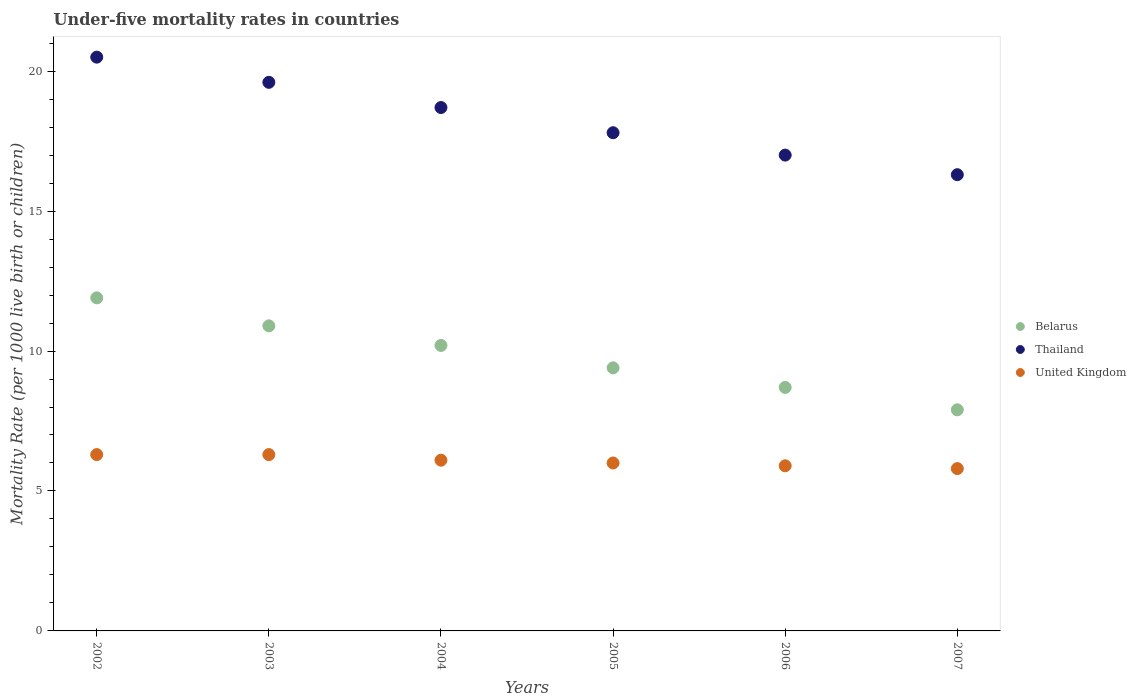How many different coloured dotlines are there?
Your answer should be compact. 3. Is the number of dotlines equal to the number of legend labels?
Provide a succinct answer. Yes. Across all years, what is the minimum under-five mortality rate in United Kingdom?
Your response must be concise. 5.8. In which year was the under-five mortality rate in Thailand maximum?
Your answer should be very brief. 2002. In which year was the under-five mortality rate in Belarus minimum?
Offer a very short reply. 2007. What is the total under-five mortality rate in Thailand in the graph?
Provide a short and direct response. 109.9. What is the difference between the under-five mortality rate in Thailand in 2002 and that in 2005?
Your answer should be compact. 2.7. What is the difference between the under-five mortality rate in United Kingdom in 2002 and the under-five mortality rate in Thailand in 2007?
Your answer should be very brief. -10. What is the average under-five mortality rate in Belarus per year?
Make the answer very short. 9.83. In the year 2007, what is the difference between the under-five mortality rate in Belarus and under-five mortality rate in United Kingdom?
Give a very brief answer. 2.1. What is the ratio of the under-five mortality rate in United Kingdom in 2004 to that in 2006?
Provide a short and direct response. 1.03. Is the under-five mortality rate in Thailand in 2002 less than that in 2007?
Your answer should be compact. No. Is the difference between the under-five mortality rate in Belarus in 2005 and 2006 greater than the difference between the under-five mortality rate in United Kingdom in 2005 and 2006?
Your answer should be very brief. Yes. What is the difference between the highest and the second highest under-five mortality rate in Thailand?
Offer a very short reply. 0.9. Is it the case that in every year, the sum of the under-five mortality rate in United Kingdom and under-five mortality rate in Belarus  is greater than the under-five mortality rate in Thailand?
Your response must be concise. No. Is the under-five mortality rate in Belarus strictly less than the under-five mortality rate in Thailand over the years?
Give a very brief answer. Yes. Are the values on the major ticks of Y-axis written in scientific E-notation?
Give a very brief answer. No. Where does the legend appear in the graph?
Ensure brevity in your answer.  Center right. What is the title of the graph?
Keep it short and to the point. Under-five mortality rates in countries. Does "Ghana" appear as one of the legend labels in the graph?
Provide a succinct answer. No. What is the label or title of the Y-axis?
Offer a very short reply. Mortality Rate (per 1000 live birth or children). What is the Mortality Rate (per 1000 live birth or children) of Belarus in 2002?
Your answer should be compact. 11.9. What is the Mortality Rate (per 1000 live birth or children) of Thailand in 2002?
Provide a short and direct response. 20.5. What is the Mortality Rate (per 1000 live birth or children) in Thailand in 2003?
Keep it short and to the point. 19.6. What is the Mortality Rate (per 1000 live birth or children) of United Kingdom in 2003?
Make the answer very short. 6.3. What is the Mortality Rate (per 1000 live birth or children) of Belarus in 2004?
Your response must be concise. 10.2. What is the Mortality Rate (per 1000 live birth or children) in Belarus in 2006?
Ensure brevity in your answer.  8.7. What is the Mortality Rate (per 1000 live birth or children) of United Kingdom in 2006?
Your response must be concise. 5.9. What is the Mortality Rate (per 1000 live birth or children) of United Kingdom in 2007?
Offer a terse response. 5.8. Across all years, what is the minimum Mortality Rate (per 1000 live birth or children) of Belarus?
Your answer should be very brief. 7.9. Across all years, what is the minimum Mortality Rate (per 1000 live birth or children) in Thailand?
Your response must be concise. 16.3. What is the total Mortality Rate (per 1000 live birth or children) of Belarus in the graph?
Your response must be concise. 59. What is the total Mortality Rate (per 1000 live birth or children) of Thailand in the graph?
Make the answer very short. 109.9. What is the total Mortality Rate (per 1000 live birth or children) of United Kingdom in the graph?
Provide a short and direct response. 36.4. What is the difference between the Mortality Rate (per 1000 live birth or children) of Belarus in 2002 and that in 2003?
Provide a short and direct response. 1. What is the difference between the Mortality Rate (per 1000 live birth or children) of Thailand in 2002 and that in 2003?
Your answer should be very brief. 0.9. What is the difference between the Mortality Rate (per 1000 live birth or children) in Thailand in 2002 and that in 2005?
Ensure brevity in your answer.  2.7. What is the difference between the Mortality Rate (per 1000 live birth or children) of United Kingdom in 2002 and that in 2005?
Provide a short and direct response. 0.3. What is the difference between the Mortality Rate (per 1000 live birth or children) in Belarus in 2002 and that in 2006?
Make the answer very short. 3.2. What is the difference between the Mortality Rate (per 1000 live birth or children) of Thailand in 2002 and that in 2006?
Make the answer very short. 3.5. What is the difference between the Mortality Rate (per 1000 live birth or children) in United Kingdom in 2002 and that in 2006?
Make the answer very short. 0.4. What is the difference between the Mortality Rate (per 1000 live birth or children) of Thailand in 2002 and that in 2007?
Offer a very short reply. 4.2. What is the difference between the Mortality Rate (per 1000 live birth or children) of Belarus in 2003 and that in 2004?
Your response must be concise. 0.7. What is the difference between the Mortality Rate (per 1000 live birth or children) in Belarus in 2003 and that in 2005?
Make the answer very short. 1.5. What is the difference between the Mortality Rate (per 1000 live birth or children) of United Kingdom in 2003 and that in 2005?
Your answer should be very brief. 0.3. What is the difference between the Mortality Rate (per 1000 live birth or children) in Belarus in 2003 and that in 2006?
Keep it short and to the point. 2.2. What is the difference between the Mortality Rate (per 1000 live birth or children) in Thailand in 2003 and that in 2006?
Your response must be concise. 2.6. What is the difference between the Mortality Rate (per 1000 live birth or children) in Belarus in 2003 and that in 2007?
Your answer should be compact. 3. What is the difference between the Mortality Rate (per 1000 live birth or children) of Thailand in 2003 and that in 2007?
Your answer should be compact. 3.3. What is the difference between the Mortality Rate (per 1000 live birth or children) of United Kingdom in 2003 and that in 2007?
Your response must be concise. 0.5. What is the difference between the Mortality Rate (per 1000 live birth or children) of Belarus in 2004 and that in 2005?
Give a very brief answer. 0.8. What is the difference between the Mortality Rate (per 1000 live birth or children) in Thailand in 2004 and that in 2005?
Ensure brevity in your answer.  0.9. What is the difference between the Mortality Rate (per 1000 live birth or children) in Thailand in 2004 and that in 2006?
Give a very brief answer. 1.7. What is the difference between the Mortality Rate (per 1000 live birth or children) in Thailand in 2004 and that in 2007?
Your response must be concise. 2.4. What is the difference between the Mortality Rate (per 1000 live birth or children) of Belarus in 2005 and that in 2006?
Ensure brevity in your answer.  0.7. What is the difference between the Mortality Rate (per 1000 live birth or children) in United Kingdom in 2005 and that in 2006?
Offer a terse response. 0.1. What is the difference between the Mortality Rate (per 1000 live birth or children) in Belarus in 2005 and that in 2007?
Your answer should be compact. 1.5. What is the difference between the Mortality Rate (per 1000 live birth or children) in United Kingdom in 2005 and that in 2007?
Ensure brevity in your answer.  0.2. What is the difference between the Mortality Rate (per 1000 live birth or children) in Thailand in 2006 and that in 2007?
Keep it short and to the point. 0.7. What is the difference between the Mortality Rate (per 1000 live birth or children) in United Kingdom in 2006 and that in 2007?
Your response must be concise. 0.1. What is the difference between the Mortality Rate (per 1000 live birth or children) in Belarus in 2002 and the Mortality Rate (per 1000 live birth or children) in Thailand in 2003?
Your response must be concise. -7.7. What is the difference between the Mortality Rate (per 1000 live birth or children) of Belarus in 2002 and the Mortality Rate (per 1000 live birth or children) of Thailand in 2004?
Keep it short and to the point. -6.8. What is the difference between the Mortality Rate (per 1000 live birth or children) of Belarus in 2002 and the Mortality Rate (per 1000 live birth or children) of United Kingdom in 2004?
Make the answer very short. 5.8. What is the difference between the Mortality Rate (per 1000 live birth or children) of Belarus in 2002 and the Mortality Rate (per 1000 live birth or children) of Thailand in 2006?
Give a very brief answer. -5.1. What is the difference between the Mortality Rate (per 1000 live birth or children) of Thailand in 2002 and the Mortality Rate (per 1000 live birth or children) of United Kingdom in 2006?
Make the answer very short. 14.6. What is the difference between the Mortality Rate (per 1000 live birth or children) in Belarus in 2002 and the Mortality Rate (per 1000 live birth or children) in Thailand in 2007?
Your answer should be very brief. -4.4. What is the difference between the Mortality Rate (per 1000 live birth or children) in Belarus in 2003 and the Mortality Rate (per 1000 live birth or children) in Thailand in 2004?
Make the answer very short. -7.8. What is the difference between the Mortality Rate (per 1000 live birth or children) in Belarus in 2003 and the Mortality Rate (per 1000 live birth or children) in United Kingdom in 2004?
Make the answer very short. 4.8. What is the difference between the Mortality Rate (per 1000 live birth or children) of Thailand in 2003 and the Mortality Rate (per 1000 live birth or children) of United Kingdom in 2004?
Give a very brief answer. 13.5. What is the difference between the Mortality Rate (per 1000 live birth or children) of Belarus in 2003 and the Mortality Rate (per 1000 live birth or children) of Thailand in 2005?
Offer a terse response. -6.9. What is the difference between the Mortality Rate (per 1000 live birth or children) of Belarus in 2003 and the Mortality Rate (per 1000 live birth or children) of United Kingdom in 2005?
Offer a very short reply. 4.9. What is the difference between the Mortality Rate (per 1000 live birth or children) in Thailand in 2003 and the Mortality Rate (per 1000 live birth or children) in United Kingdom in 2005?
Make the answer very short. 13.6. What is the difference between the Mortality Rate (per 1000 live birth or children) of Belarus in 2003 and the Mortality Rate (per 1000 live birth or children) of Thailand in 2006?
Ensure brevity in your answer.  -6.1. What is the difference between the Mortality Rate (per 1000 live birth or children) of Thailand in 2003 and the Mortality Rate (per 1000 live birth or children) of United Kingdom in 2006?
Give a very brief answer. 13.7. What is the difference between the Mortality Rate (per 1000 live birth or children) of Belarus in 2004 and the Mortality Rate (per 1000 live birth or children) of Thailand in 2005?
Ensure brevity in your answer.  -7.6. What is the difference between the Mortality Rate (per 1000 live birth or children) of Belarus in 2004 and the Mortality Rate (per 1000 live birth or children) of United Kingdom in 2005?
Offer a very short reply. 4.2. What is the difference between the Mortality Rate (per 1000 live birth or children) in Thailand in 2004 and the Mortality Rate (per 1000 live birth or children) in United Kingdom in 2005?
Your answer should be very brief. 12.7. What is the difference between the Mortality Rate (per 1000 live birth or children) in Belarus in 2004 and the Mortality Rate (per 1000 live birth or children) in United Kingdom in 2007?
Provide a short and direct response. 4.4. What is the difference between the Mortality Rate (per 1000 live birth or children) in Thailand in 2004 and the Mortality Rate (per 1000 live birth or children) in United Kingdom in 2007?
Offer a terse response. 12.9. What is the difference between the Mortality Rate (per 1000 live birth or children) in Belarus in 2005 and the Mortality Rate (per 1000 live birth or children) in United Kingdom in 2006?
Offer a very short reply. 3.5. What is the difference between the Mortality Rate (per 1000 live birth or children) of Belarus in 2005 and the Mortality Rate (per 1000 live birth or children) of Thailand in 2007?
Keep it short and to the point. -6.9. What is the difference between the Mortality Rate (per 1000 live birth or children) of Belarus in 2005 and the Mortality Rate (per 1000 live birth or children) of United Kingdom in 2007?
Provide a short and direct response. 3.6. What is the difference between the Mortality Rate (per 1000 live birth or children) of Thailand in 2005 and the Mortality Rate (per 1000 live birth or children) of United Kingdom in 2007?
Give a very brief answer. 12. What is the difference between the Mortality Rate (per 1000 live birth or children) of Thailand in 2006 and the Mortality Rate (per 1000 live birth or children) of United Kingdom in 2007?
Offer a very short reply. 11.2. What is the average Mortality Rate (per 1000 live birth or children) of Belarus per year?
Provide a short and direct response. 9.83. What is the average Mortality Rate (per 1000 live birth or children) of Thailand per year?
Offer a very short reply. 18.32. What is the average Mortality Rate (per 1000 live birth or children) in United Kingdom per year?
Make the answer very short. 6.07. In the year 2002, what is the difference between the Mortality Rate (per 1000 live birth or children) of Belarus and Mortality Rate (per 1000 live birth or children) of Thailand?
Make the answer very short. -8.6. In the year 2002, what is the difference between the Mortality Rate (per 1000 live birth or children) in Belarus and Mortality Rate (per 1000 live birth or children) in United Kingdom?
Keep it short and to the point. 5.6. In the year 2002, what is the difference between the Mortality Rate (per 1000 live birth or children) in Thailand and Mortality Rate (per 1000 live birth or children) in United Kingdom?
Offer a terse response. 14.2. In the year 2003, what is the difference between the Mortality Rate (per 1000 live birth or children) of Belarus and Mortality Rate (per 1000 live birth or children) of United Kingdom?
Your answer should be very brief. 4.6. In the year 2004, what is the difference between the Mortality Rate (per 1000 live birth or children) of Belarus and Mortality Rate (per 1000 live birth or children) of Thailand?
Give a very brief answer. -8.5. In the year 2004, what is the difference between the Mortality Rate (per 1000 live birth or children) in Thailand and Mortality Rate (per 1000 live birth or children) in United Kingdom?
Give a very brief answer. 12.6. In the year 2005, what is the difference between the Mortality Rate (per 1000 live birth or children) of Belarus and Mortality Rate (per 1000 live birth or children) of United Kingdom?
Offer a terse response. 3.4. In the year 2005, what is the difference between the Mortality Rate (per 1000 live birth or children) of Thailand and Mortality Rate (per 1000 live birth or children) of United Kingdom?
Provide a short and direct response. 11.8. In the year 2006, what is the difference between the Mortality Rate (per 1000 live birth or children) of Belarus and Mortality Rate (per 1000 live birth or children) of United Kingdom?
Your answer should be very brief. 2.8. In the year 2007, what is the difference between the Mortality Rate (per 1000 live birth or children) in Belarus and Mortality Rate (per 1000 live birth or children) in United Kingdom?
Provide a short and direct response. 2.1. In the year 2007, what is the difference between the Mortality Rate (per 1000 live birth or children) of Thailand and Mortality Rate (per 1000 live birth or children) of United Kingdom?
Ensure brevity in your answer.  10.5. What is the ratio of the Mortality Rate (per 1000 live birth or children) of Belarus in 2002 to that in 2003?
Your answer should be compact. 1.09. What is the ratio of the Mortality Rate (per 1000 live birth or children) of Thailand in 2002 to that in 2003?
Ensure brevity in your answer.  1.05. What is the ratio of the Mortality Rate (per 1000 live birth or children) of United Kingdom in 2002 to that in 2003?
Give a very brief answer. 1. What is the ratio of the Mortality Rate (per 1000 live birth or children) of Belarus in 2002 to that in 2004?
Provide a short and direct response. 1.17. What is the ratio of the Mortality Rate (per 1000 live birth or children) of Thailand in 2002 to that in 2004?
Keep it short and to the point. 1.1. What is the ratio of the Mortality Rate (per 1000 live birth or children) in United Kingdom in 2002 to that in 2004?
Make the answer very short. 1.03. What is the ratio of the Mortality Rate (per 1000 live birth or children) of Belarus in 2002 to that in 2005?
Offer a very short reply. 1.27. What is the ratio of the Mortality Rate (per 1000 live birth or children) of Thailand in 2002 to that in 2005?
Provide a succinct answer. 1.15. What is the ratio of the Mortality Rate (per 1000 live birth or children) of Belarus in 2002 to that in 2006?
Make the answer very short. 1.37. What is the ratio of the Mortality Rate (per 1000 live birth or children) of Thailand in 2002 to that in 2006?
Provide a short and direct response. 1.21. What is the ratio of the Mortality Rate (per 1000 live birth or children) in United Kingdom in 2002 to that in 2006?
Ensure brevity in your answer.  1.07. What is the ratio of the Mortality Rate (per 1000 live birth or children) of Belarus in 2002 to that in 2007?
Your answer should be very brief. 1.51. What is the ratio of the Mortality Rate (per 1000 live birth or children) of Thailand in 2002 to that in 2007?
Offer a terse response. 1.26. What is the ratio of the Mortality Rate (per 1000 live birth or children) in United Kingdom in 2002 to that in 2007?
Ensure brevity in your answer.  1.09. What is the ratio of the Mortality Rate (per 1000 live birth or children) in Belarus in 2003 to that in 2004?
Your answer should be very brief. 1.07. What is the ratio of the Mortality Rate (per 1000 live birth or children) of Thailand in 2003 to that in 2004?
Make the answer very short. 1.05. What is the ratio of the Mortality Rate (per 1000 live birth or children) of United Kingdom in 2003 to that in 2004?
Your answer should be very brief. 1.03. What is the ratio of the Mortality Rate (per 1000 live birth or children) of Belarus in 2003 to that in 2005?
Offer a terse response. 1.16. What is the ratio of the Mortality Rate (per 1000 live birth or children) of Thailand in 2003 to that in 2005?
Your answer should be very brief. 1.1. What is the ratio of the Mortality Rate (per 1000 live birth or children) in United Kingdom in 2003 to that in 2005?
Your answer should be very brief. 1.05. What is the ratio of the Mortality Rate (per 1000 live birth or children) of Belarus in 2003 to that in 2006?
Give a very brief answer. 1.25. What is the ratio of the Mortality Rate (per 1000 live birth or children) of Thailand in 2003 to that in 2006?
Offer a terse response. 1.15. What is the ratio of the Mortality Rate (per 1000 live birth or children) of United Kingdom in 2003 to that in 2006?
Give a very brief answer. 1.07. What is the ratio of the Mortality Rate (per 1000 live birth or children) in Belarus in 2003 to that in 2007?
Your response must be concise. 1.38. What is the ratio of the Mortality Rate (per 1000 live birth or children) in Thailand in 2003 to that in 2007?
Offer a terse response. 1.2. What is the ratio of the Mortality Rate (per 1000 live birth or children) in United Kingdom in 2003 to that in 2007?
Keep it short and to the point. 1.09. What is the ratio of the Mortality Rate (per 1000 live birth or children) in Belarus in 2004 to that in 2005?
Ensure brevity in your answer.  1.09. What is the ratio of the Mortality Rate (per 1000 live birth or children) of Thailand in 2004 to that in 2005?
Your response must be concise. 1.05. What is the ratio of the Mortality Rate (per 1000 live birth or children) in United Kingdom in 2004 to that in 2005?
Offer a terse response. 1.02. What is the ratio of the Mortality Rate (per 1000 live birth or children) of Belarus in 2004 to that in 2006?
Provide a succinct answer. 1.17. What is the ratio of the Mortality Rate (per 1000 live birth or children) of Thailand in 2004 to that in 2006?
Your answer should be compact. 1.1. What is the ratio of the Mortality Rate (per 1000 live birth or children) of United Kingdom in 2004 to that in 2006?
Your answer should be very brief. 1.03. What is the ratio of the Mortality Rate (per 1000 live birth or children) of Belarus in 2004 to that in 2007?
Provide a short and direct response. 1.29. What is the ratio of the Mortality Rate (per 1000 live birth or children) in Thailand in 2004 to that in 2007?
Ensure brevity in your answer.  1.15. What is the ratio of the Mortality Rate (per 1000 live birth or children) of United Kingdom in 2004 to that in 2007?
Provide a short and direct response. 1.05. What is the ratio of the Mortality Rate (per 1000 live birth or children) of Belarus in 2005 to that in 2006?
Your response must be concise. 1.08. What is the ratio of the Mortality Rate (per 1000 live birth or children) in Thailand in 2005 to that in 2006?
Offer a terse response. 1.05. What is the ratio of the Mortality Rate (per 1000 live birth or children) of United Kingdom in 2005 to that in 2006?
Offer a terse response. 1.02. What is the ratio of the Mortality Rate (per 1000 live birth or children) in Belarus in 2005 to that in 2007?
Your response must be concise. 1.19. What is the ratio of the Mortality Rate (per 1000 live birth or children) in Thailand in 2005 to that in 2007?
Keep it short and to the point. 1.09. What is the ratio of the Mortality Rate (per 1000 live birth or children) in United Kingdom in 2005 to that in 2007?
Keep it short and to the point. 1.03. What is the ratio of the Mortality Rate (per 1000 live birth or children) of Belarus in 2006 to that in 2007?
Make the answer very short. 1.1. What is the ratio of the Mortality Rate (per 1000 live birth or children) in Thailand in 2006 to that in 2007?
Give a very brief answer. 1.04. What is the ratio of the Mortality Rate (per 1000 live birth or children) of United Kingdom in 2006 to that in 2007?
Make the answer very short. 1.02. What is the difference between the highest and the second highest Mortality Rate (per 1000 live birth or children) in Belarus?
Offer a terse response. 1. What is the difference between the highest and the lowest Mortality Rate (per 1000 live birth or children) of Belarus?
Make the answer very short. 4. What is the difference between the highest and the lowest Mortality Rate (per 1000 live birth or children) of Thailand?
Keep it short and to the point. 4.2. 